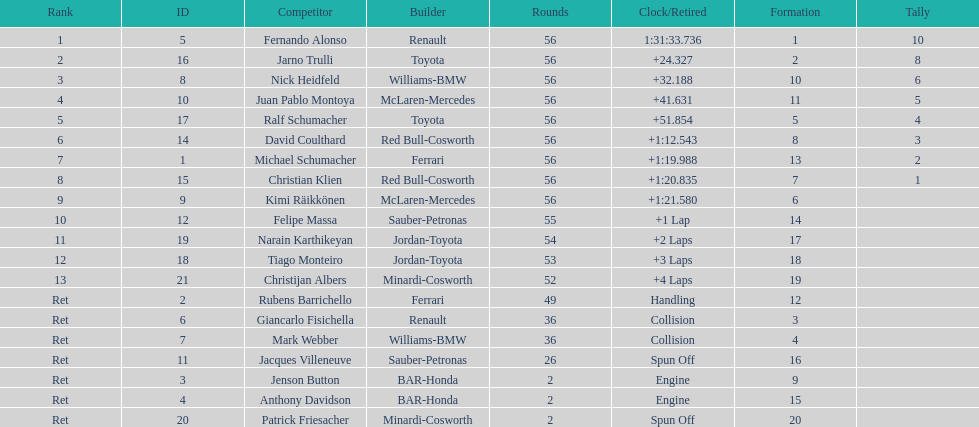How many bmws finished before webber? 1. 